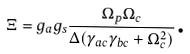<formula> <loc_0><loc_0><loc_500><loc_500>\Xi = g _ { a } g _ { s } \frac { \Omega _ { p } \Omega _ { c } } { \Delta ( \gamma _ { a c } \gamma _ { b c } + \Omega _ { c } ^ { 2 } ) } \text {.}</formula> 